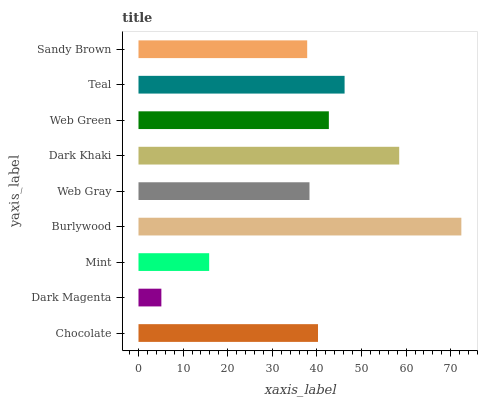Is Dark Magenta the minimum?
Answer yes or no. Yes. Is Burlywood the maximum?
Answer yes or no. Yes. Is Mint the minimum?
Answer yes or no. No. Is Mint the maximum?
Answer yes or no. No. Is Mint greater than Dark Magenta?
Answer yes or no. Yes. Is Dark Magenta less than Mint?
Answer yes or no. Yes. Is Dark Magenta greater than Mint?
Answer yes or no. No. Is Mint less than Dark Magenta?
Answer yes or no. No. Is Chocolate the high median?
Answer yes or no. Yes. Is Chocolate the low median?
Answer yes or no. Yes. Is Teal the high median?
Answer yes or no. No. Is Web Gray the low median?
Answer yes or no. No. 